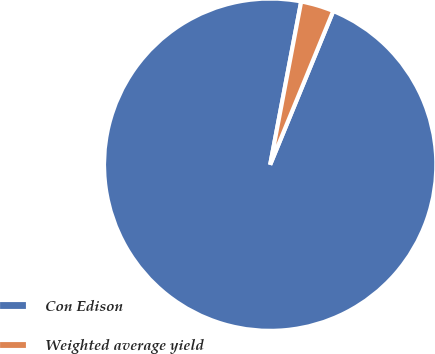Convert chart. <chart><loc_0><loc_0><loc_500><loc_500><pie_chart><fcel>Con Edison<fcel>Weighted average yield<nl><fcel>96.79%<fcel>3.21%<nl></chart> 